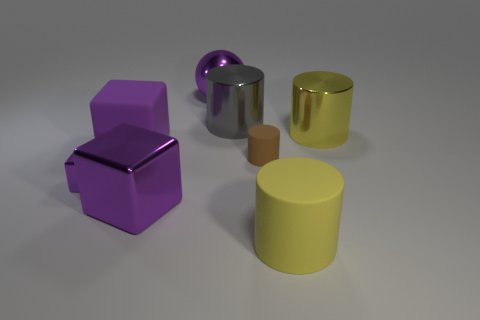What material is the other yellow cylinder that is the same size as the yellow rubber cylinder?
Your answer should be very brief. Metal. Are there any purple things of the same shape as the large gray thing?
Your response must be concise. No. There is a tiny thing that is the same color as the metallic ball; what is its material?
Give a very brief answer. Metal. There is a yellow thing in front of the small metallic thing; what is its shape?
Keep it short and to the point. Cylinder. What number of large yellow things are there?
Keep it short and to the point. 2. What color is the cube that is the same material as the tiny brown object?
Provide a short and direct response. Purple. How many large things are either cyan things or rubber blocks?
Offer a terse response. 1. What number of big gray cylinders are in front of the yellow metal cylinder?
Offer a terse response. 0. What is the color of the large matte object that is the same shape as the small metal thing?
Your answer should be compact. Purple. What number of matte things are tiny cylinders or large gray cubes?
Make the answer very short. 1. 